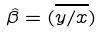Convert formula to latex. <formula><loc_0><loc_0><loc_500><loc_500>\hat { \beta } = ( \overline { y / x } )</formula> 